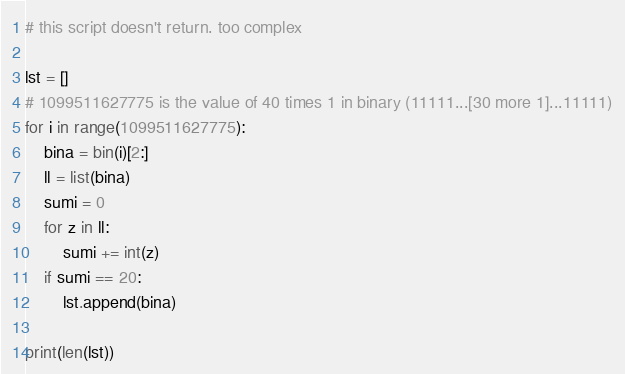Convert code to text. <code><loc_0><loc_0><loc_500><loc_500><_Python_># this script doesn't return. too complex

lst = []
# 1099511627775 is the value of 40 times 1 in binary (11111...[30 more 1]...11111)
for i in range(1099511627775):
    bina = bin(i)[2:]
    ll = list(bina)
    sumi = 0
    for z in ll:
        sumi += int(z)
    if sumi == 20:
        lst.append(bina)

print(len(lst))
</code> 